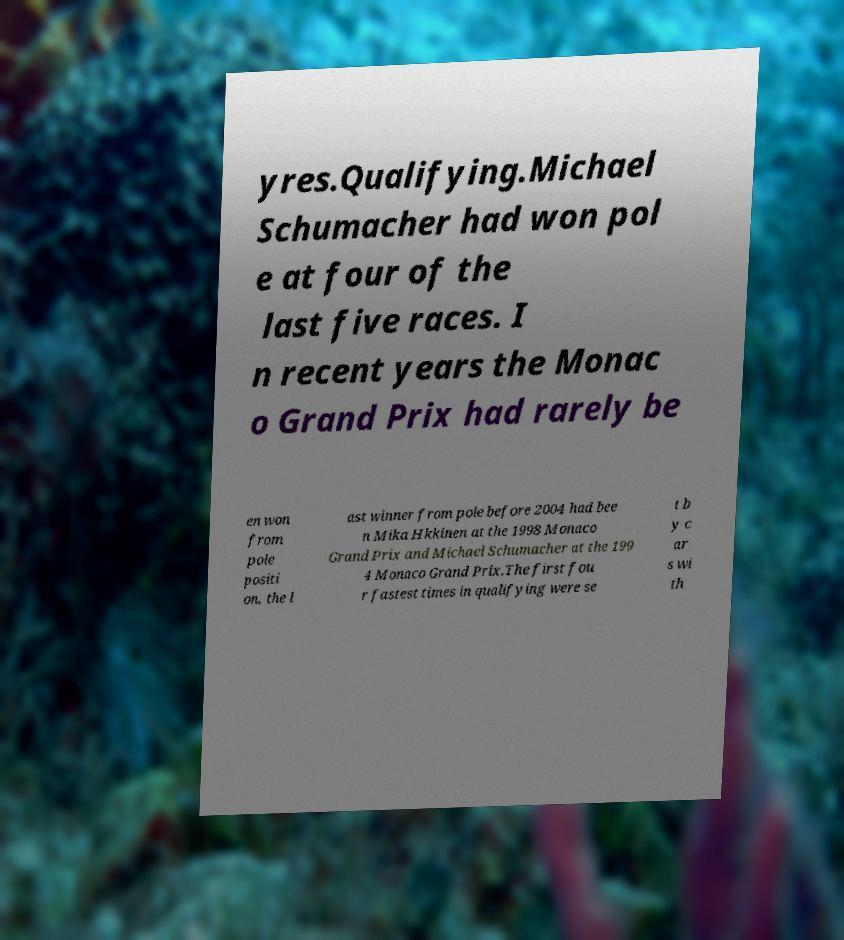Can you read and provide the text displayed in the image?This photo seems to have some interesting text. Can you extract and type it out for me? yres.Qualifying.Michael Schumacher had won pol e at four of the last five races. I n recent years the Monac o Grand Prix had rarely be en won from pole positi on, the l ast winner from pole before 2004 had bee n Mika Hkkinen at the 1998 Monaco Grand Prix and Michael Schumacher at the 199 4 Monaco Grand Prix.The first fou r fastest times in qualifying were se t b y c ar s wi th 